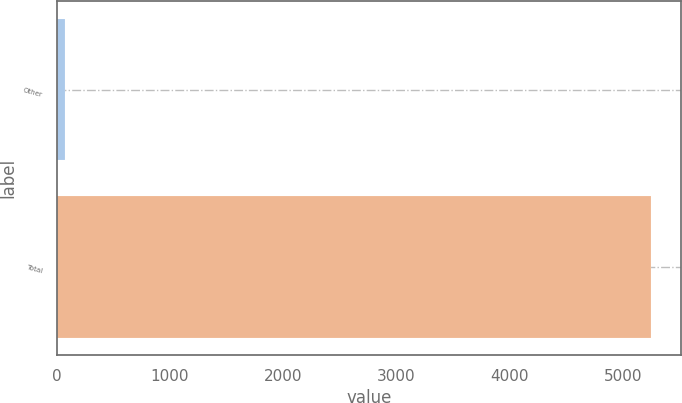Convert chart. <chart><loc_0><loc_0><loc_500><loc_500><bar_chart><fcel>Other<fcel>Total<nl><fcel>77<fcel>5253<nl></chart> 